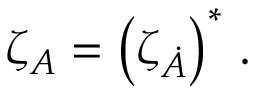<formula> <loc_0><loc_0><loc_500><loc_500>\zeta _ { A } = \left ( \zeta _ { \dot { A } } \right ) ^ { * } \, .</formula> 